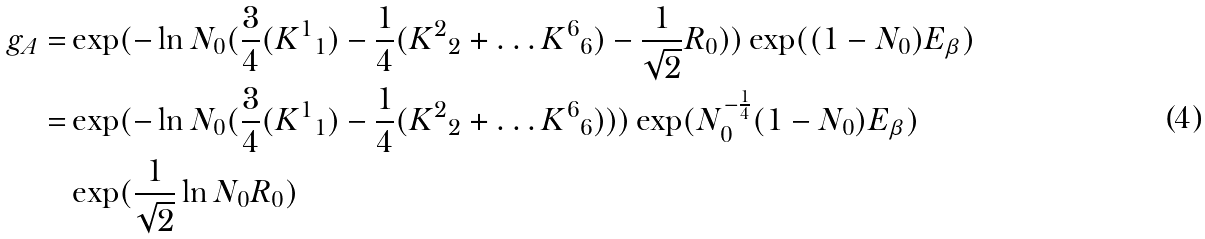<formula> <loc_0><loc_0><loc_500><loc_500>g _ { A } = & \exp ( - \ln N _ { 0 } ( \frac { 3 } { 4 } ( { K ^ { 1 } } _ { 1 } ) - \frac { 1 } { 4 } ( { K ^ { 2 } } _ { 2 } + \dots { K ^ { 6 } } _ { 6 } ) - \frac { 1 } { \sqrt { 2 } } R _ { 0 } ) ) \exp ( ( 1 - N _ { 0 } ) E _ { \beta } ) \\ = & \exp ( - \ln N _ { 0 } ( \frac { 3 } { 4 } ( { K ^ { 1 } } _ { 1 } ) - \frac { 1 } { 4 } ( { K ^ { 2 } } _ { 2 } + \dots { K ^ { 6 } } _ { 6 } ) ) ) \exp ( N _ { 0 } ^ { - \frac { 1 } { 4 } } ( 1 - N _ { 0 } ) E _ { \beta } ) \\ & \exp ( \frac { 1 } { \sqrt { 2 } } \ln N _ { 0 } R _ { 0 } )</formula> 